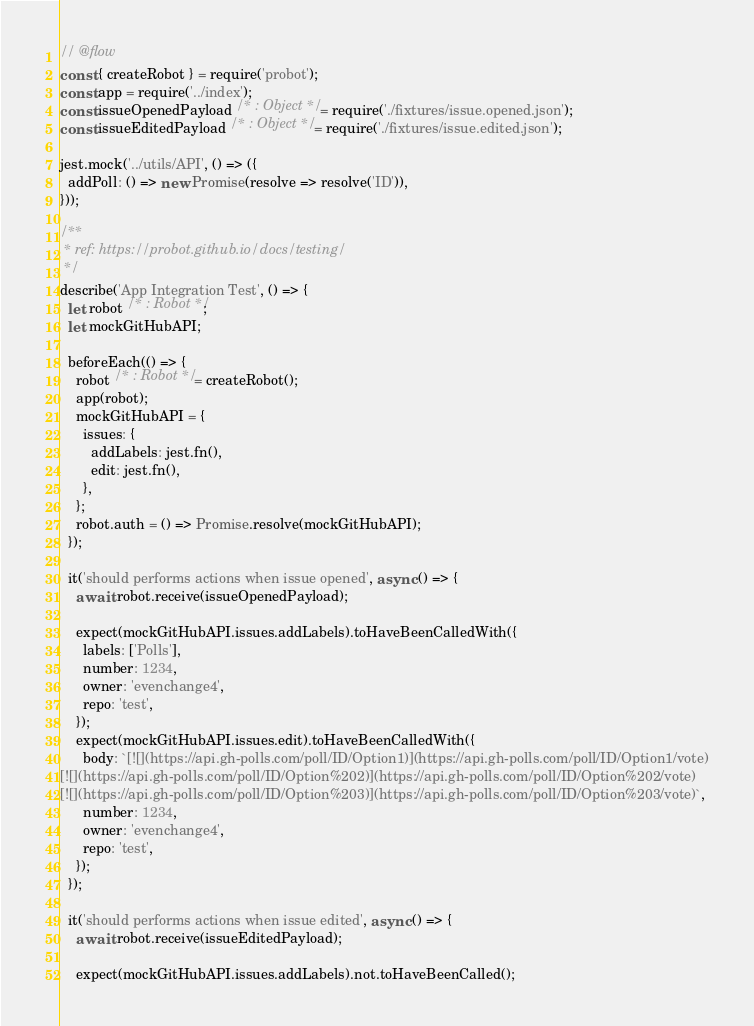<code> <loc_0><loc_0><loc_500><loc_500><_JavaScript_>// @flow
const { createRobot } = require('probot');
const app = require('../index');
const issueOpenedPayload /* : Object */ = require('./fixtures/issue.opened.json');
const issueEditedPayload /* : Object */ = require('./fixtures/issue.edited.json');

jest.mock('../utils/API', () => ({
  addPoll: () => new Promise(resolve => resolve('ID')),
}));

/**
 * ref: https://probot.github.io/docs/testing/
 */
describe('App Integration Test', () => {
  let robot /* : Robot */;
  let mockGitHubAPI;

  beforeEach(() => {
    robot /* : Robot */ = createRobot();
    app(robot);
    mockGitHubAPI = {
      issues: {
        addLabels: jest.fn(),
        edit: jest.fn(),
      },
    };
    robot.auth = () => Promise.resolve(mockGitHubAPI);
  });

  it('should performs actions when issue opened', async () => {
    await robot.receive(issueOpenedPayload);

    expect(mockGitHubAPI.issues.addLabels).toHaveBeenCalledWith({
      labels: ['Polls'],
      number: 1234,
      owner: 'evenchange4',
      repo: 'test',
    });
    expect(mockGitHubAPI.issues.edit).toHaveBeenCalledWith({
      body: `[![](https://api.gh-polls.com/poll/ID/Option1)](https://api.gh-polls.com/poll/ID/Option1/vote)
[![](https://api.gh-polls.com/poll/ID/Option%202)](https://api.gh-polls.com/poll/ID/Option%202/vote)
[![](https://api.gh-polls.com/poll/ID/Option%203)](https://api.gh-polls.com/poll/ID/Option%203/vote)`,
      number: 1234,
      owner: 'evenchange4',
      repo: 'test',
    });
  });

  it('should performs actions when issue edited', async () => {
    await robot.receive(issueEditedPayload);

    expect(mockGitHubAPI.issues.addLabels).not.toHaveBeenCalled();</code> 